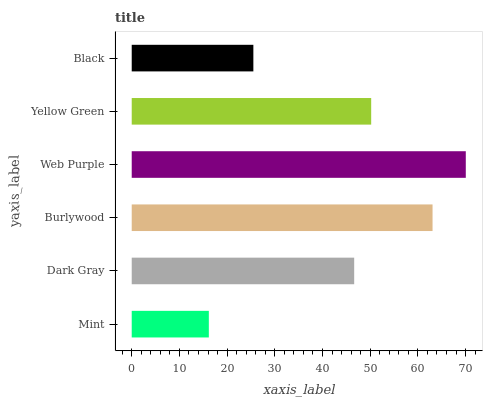Is Mint the minimum?
Answer yes or no. Yes. Is Web Purple the maximum?
Answer yes or no. Yes. Is Dark Gray the minimum?
Answer yes or no. No. Is Dark Gray the maximum?
Answer yes or no. No. Is Dark Gray greater than Mint?
Answer yes or no. Yes. Is Mint less than Dark Gray?
Answer yes or no. Yes. Is Mint greater than Dark Gray?
Answer yes or no. No. Is Dark Gray less than Mint?
Answer yes or no. No. Is Yellow Green the high median?
Answer yes or no. Yes. Is Dark Gray the low median?
Answer yes or no. Yes. Is Burlywood the high median?
Answer yes or no. No. Is Burlywood the low median?
Answer yes or no. No. 